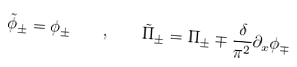<formula> <loc_0><loc_0><loc_500><loc_500>\tilde { \phi } _ { \pm } = \phi _ { \pm } \quad , \quad \tilde { \Pi } _ { \pm } = \Pi _ { \pm } \mp \frac { \delta } { \pi ^ { 2 } } \partial _ { x } \phi _ { \mp }</formula> 